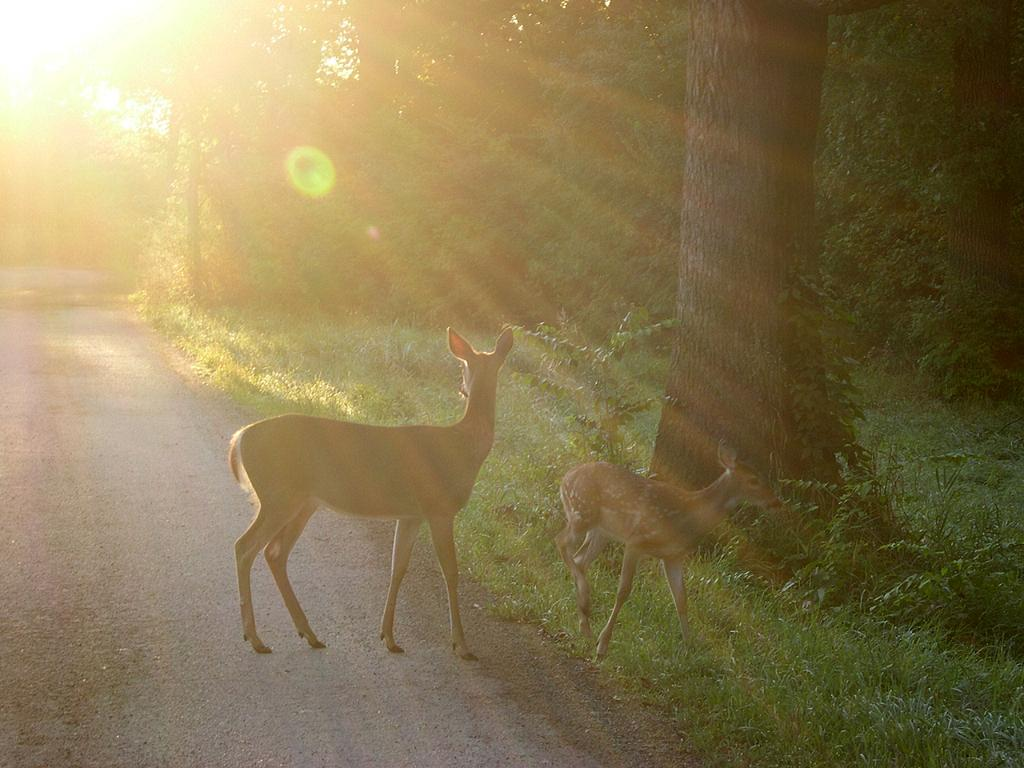What animals can be seen in the image? There are deers in the image. What is the deers' position in relation to the ground? The deers are standing on the ground. What can be seen in the background of the image? There is a road, grass, plants, sunlight, and trees visible in the background of the image. What type of butter is being used to grease the bike in the image? There is no bike or butter present in the image; it features deers standing on the ground with a background that includes a road, grass, plants, sunlight, and trees. 